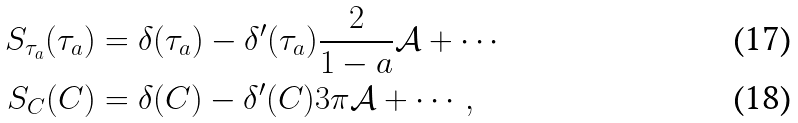Convert formula to latex. <formula><loc_0><loc_0><loc_500><loc_500>S _ { \tau _ { a } } ( \tau _ { a } ) & = \delta ( \tau _ { a } ) - \delta ^ { \prime } ( \tau _ { a } ) \frac { 2 } { 1 - a } \mathcal { A } + \cdots \\ S _ { C } ( C ) & = \delta ( C ) - \delta ^ { \prime } ( C ) 3 \pi \mathcal { A } + \cdots ,</formula> 